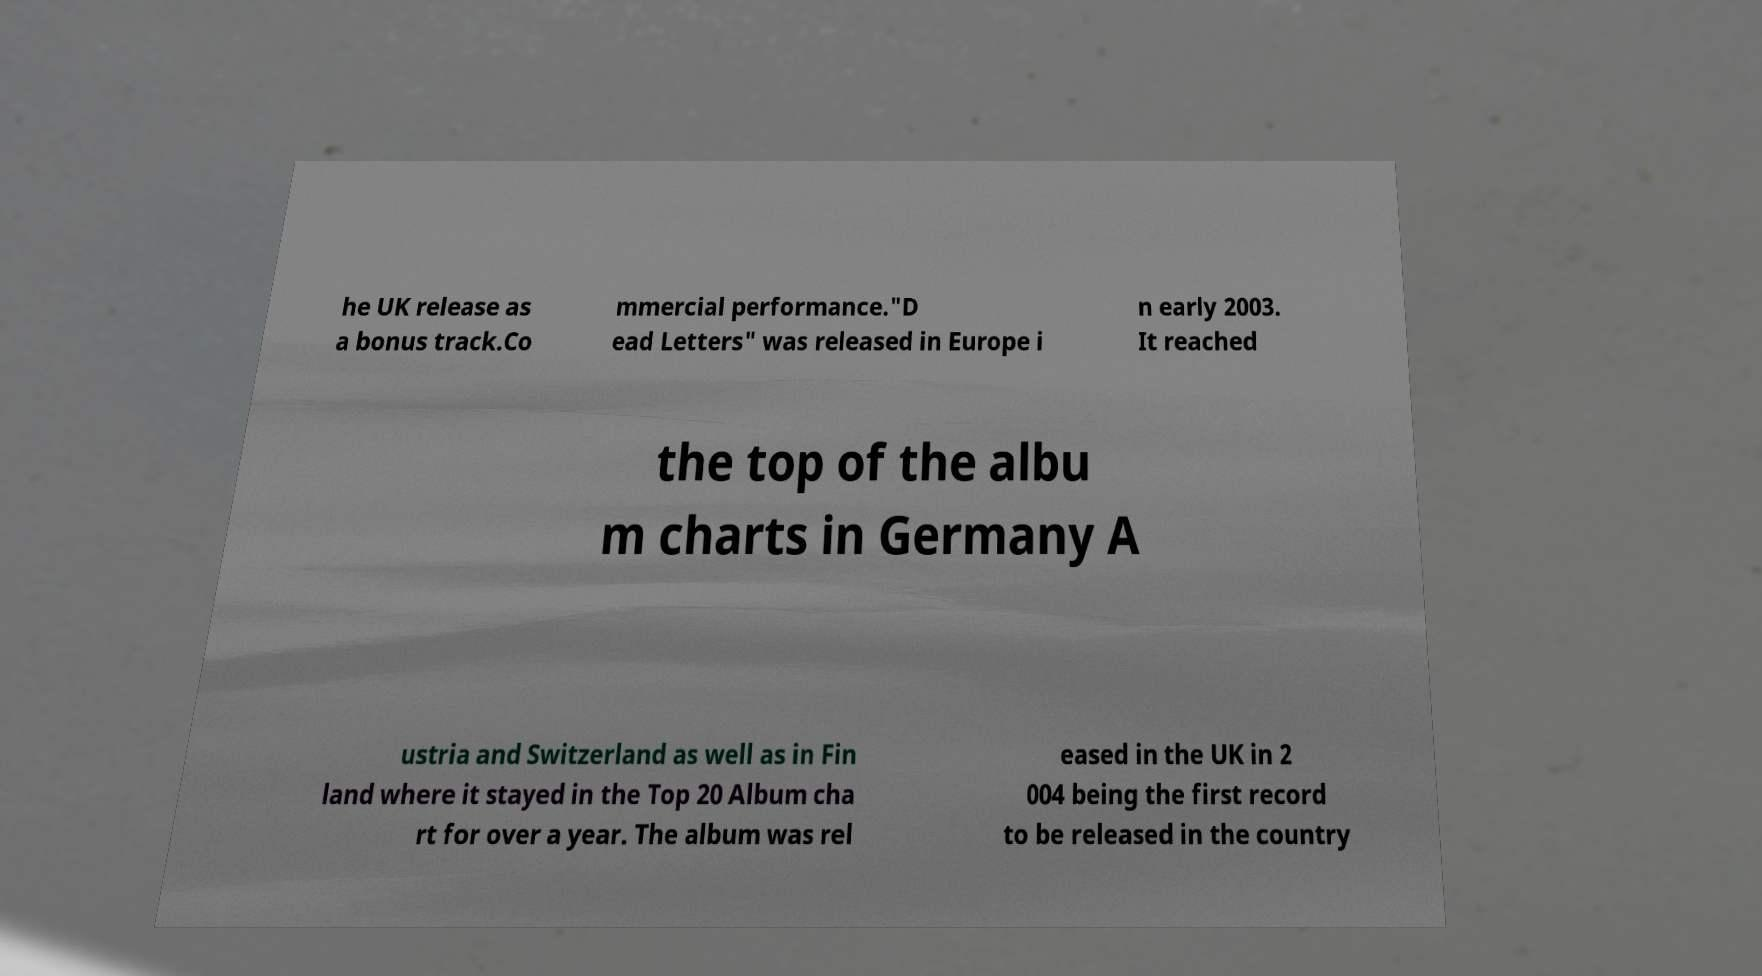What messages or text are displayed in this image? I need them in a readable, typed format. he UK release as a bonus track.Co mmercial performance."D ead Letters" was released in Europe i n early 2003. It reached the top of the albu m charts in Germany A ustria and Switzerland as well as in Fin land where it stayed in the Top 20 Album cha rt for over a year. The album was rel eased in the UK in 2 004 being the first record to be released in the country 